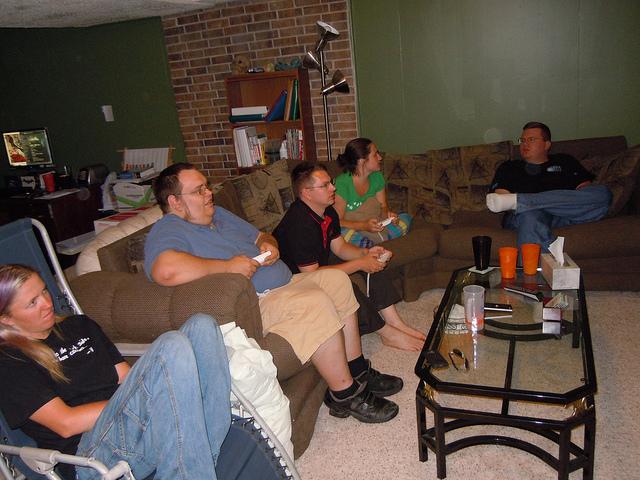What is the coffee table made of?
Keep it brief. Glass. How many people are wearing glasses?
Write a very short answer. 3. How many people are sitting?
Concise answer only. 5. Where are the people sitting at?
Concise answer only. Living room. What shape is the table?
Write a very short answer. Rectangle. What are they watching?
Give a very brief answer. Tv. What holiday season is this?
Be succinct. Christmas. How many orange cups are there?
Be succinct. 2. How many males?
Short answer required. 3. 